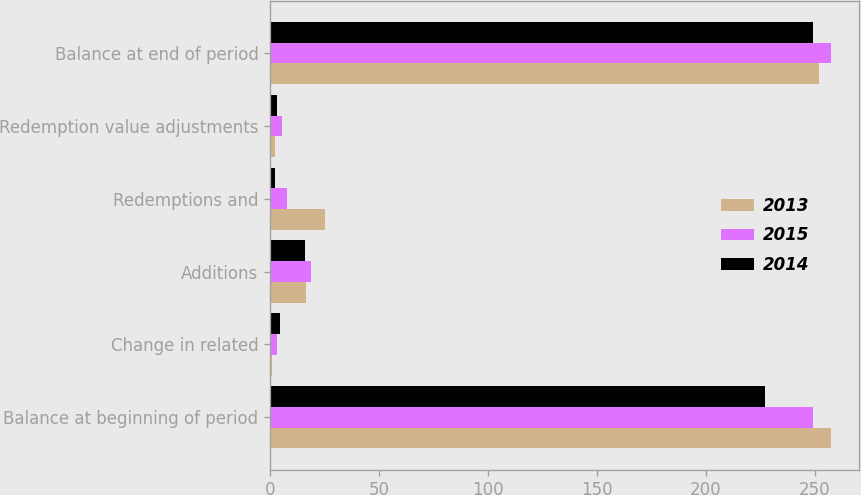<chart> <loc_0><loc_0><loc_500><loc_500><stacked_bar_chart><ecel><fcel>Balance at beginning of period<fcel>Change in related<fcel>Additions<fcel>Redemptions and<fcel>Redemption value adjustments<fcel>Balance at end of period<nl><fcel>2013<fcel>257.4<fcel>0.8<fcel>16.5<fcel>25.1<fcel>2.3<fcel>251.9<nl><fcel>2015<fcel>249.1<fcel>3.2<fcel>18.7<fcel>7.9<fcel>5.7<fcel>257.4<nl><fcel>2014<fcel>227.2<fcel>4.6<fcel>16.2<fcel>2.3<fcel>3.4<fcel>249.1<nl></chart> 